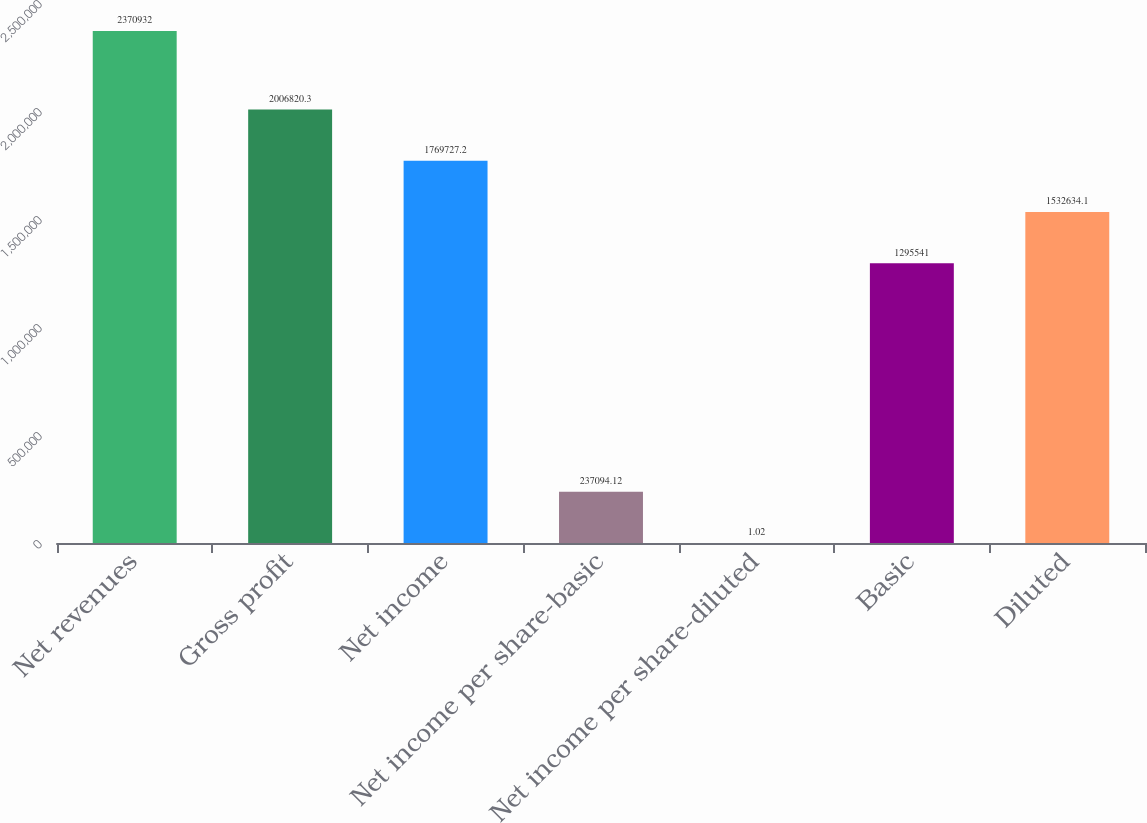Convert chart to OTSL. <chart><loc_0><loc_0><loc_500><loc_500><bar_chart><fcel>Net revenues<fcel>Gross profit<fcel>Net income<fcel>Net income per share-basic<fcel>Net income per share-diluted<fcel>Basic<fcel>Diluted<nl><fcel>2.37093e+06<fcel>2.00682e+06<fcel>1.76973e+06<fcel>237094<fcel>1.02<fcel>1.29554e+06<fcel>1.53263e+06<nl></chart> 